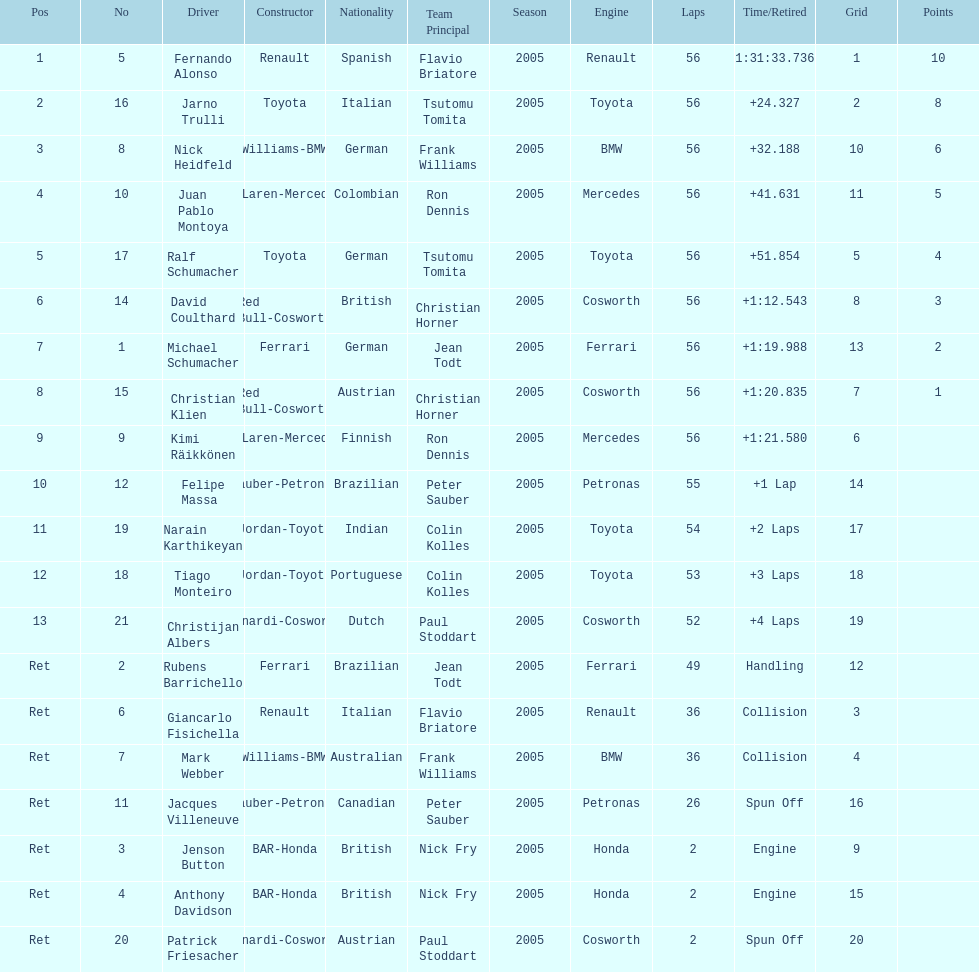How many germans finished in the top five? 2. 